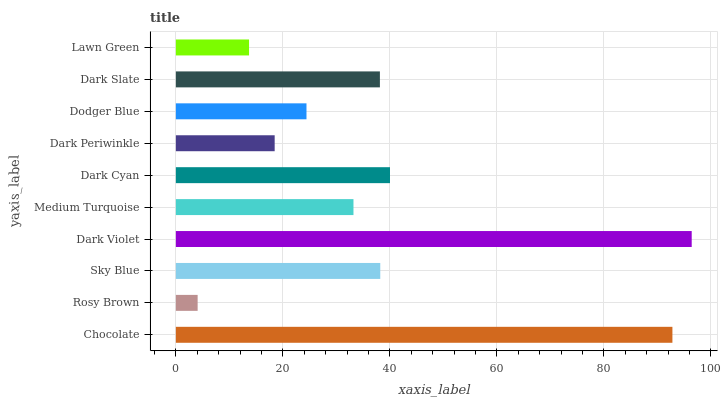Is Rosy Brown the minimum?
Answer yes or no. Yes. Is Dark Violet the maximum?
Answer yes or no. Yes. Is Sky Blue the minimum?
Answer yes or no. No. Is Sky Blue the maximum?
Answer yes or no. No. Is Sky Blue greater than Rosy Brown?
Answer yes or no. Yes. Is Rosy Brown less than Sky Blue?
Answer yes or no. Yes. Is Rosy Brown greater than Sky Blue?
Answer yes or no. No. Is Sky Blue less than Rosy Brown?
Answer yes or no. No. Is Dark Slate the high median?
Answer yes or no. Yes. Is Medium Turquoise the low median?
Answer yes or no. Yes. Is Dodger Blue the high median?
Answer yes or no. No. Is Dark Periwinkle the low median?
Answer yes or no. No. 